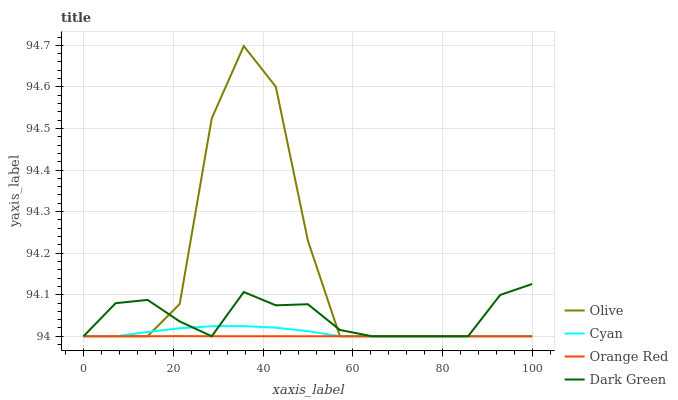Does Orange Red have the minimum area under the curve?
Answer yes or no. Yes. Does Olive have the maximum area under the curve?
Answer yes or no. Yes. Does Cyan have the minimum area under the curve?
Answer yes or no. No. Does Cyan have the maximum area under the curve?
Answer yes or no. No. Is Orange Red the smoothest?
Answer yes or no. Yes. Is Olive the roughest?
Answer yes or no. Yes. Is Cyan the smoothest?
Answer yes or no. No. Is Cyan the roughest?
Answer yes or no. No. Does Olive have the lowest value?
Answer yes or no. Yes. Does Olive have the highest value?
Answer yes or no. Yes. Does Cyan have the highest value?
Answer yes or no. No. Does Dark Green intersect Cyan?
Answer yes or no. Yes. Is Dark Green less than Cyan?
Answer yes or no. No. Is Dark Green greater than Cyan?
Answer yes or no. No. 